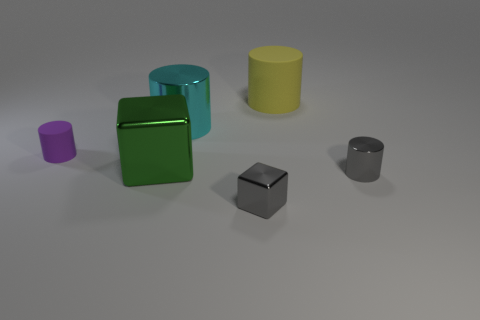Add 1 yellow things. How many objects exist? 7 Subtract all blocks. How many objects are left? 4 Subtract 0 red spheres. How many objects are left? 6 Subtract all small shiny things. Subtract all gray shiny cylinders. How many objects are left? 3 Add 6 cyan metallic things. How many cyan metallic things are left? 7 Add 1 big cyan shiny things. How many big cyan shiny things exist? 2 